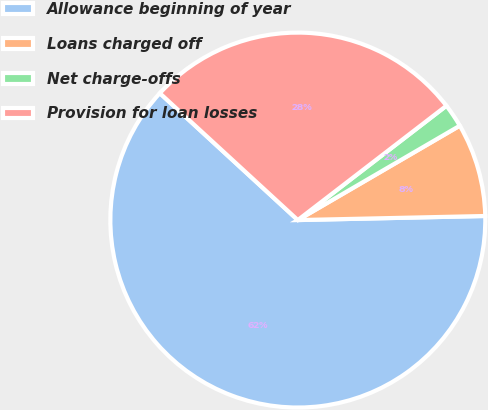Convert chart. <chart><loc_0><loc_0><loc_500><loc_500><pie_chart><fcel>Allowance beginning of year<fcel>Loans charged off<fcel>Net charge-offs<fcel>Provision for loan losses<nl><fcel>62.18%<fcel>8.05%<fcel>2.04%<fcel>27.73%<nl></chart> 